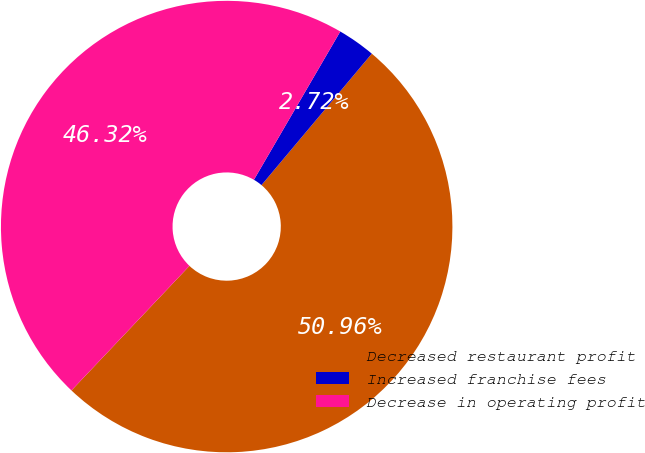Convert chart to OTSL. <chart><loc_0><loc_0><loc_500><loc_500><pie_chart><fcel>Decreased restaurant profit<fcel>Increased franchise fees<fcel>Decrease in operating profit<nl><fcel>50.95%<fcel>2.72%<fcel>46.32%<nl></chart> 